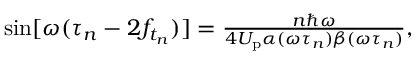<formula> <loc_0><loc_0><loc_500><loc_500>\begin{array} { r } { \sin [ \omega ( \tau _ { n } - 2 f _ { t _ { n } } ) ] = \frac { n \hbar { \omega } } { 4 U _ { p } \alpha ( \omega \tau _ { n } ) \beta ( \omega \tau _ { n } ) } , } \end{array}</formula> 